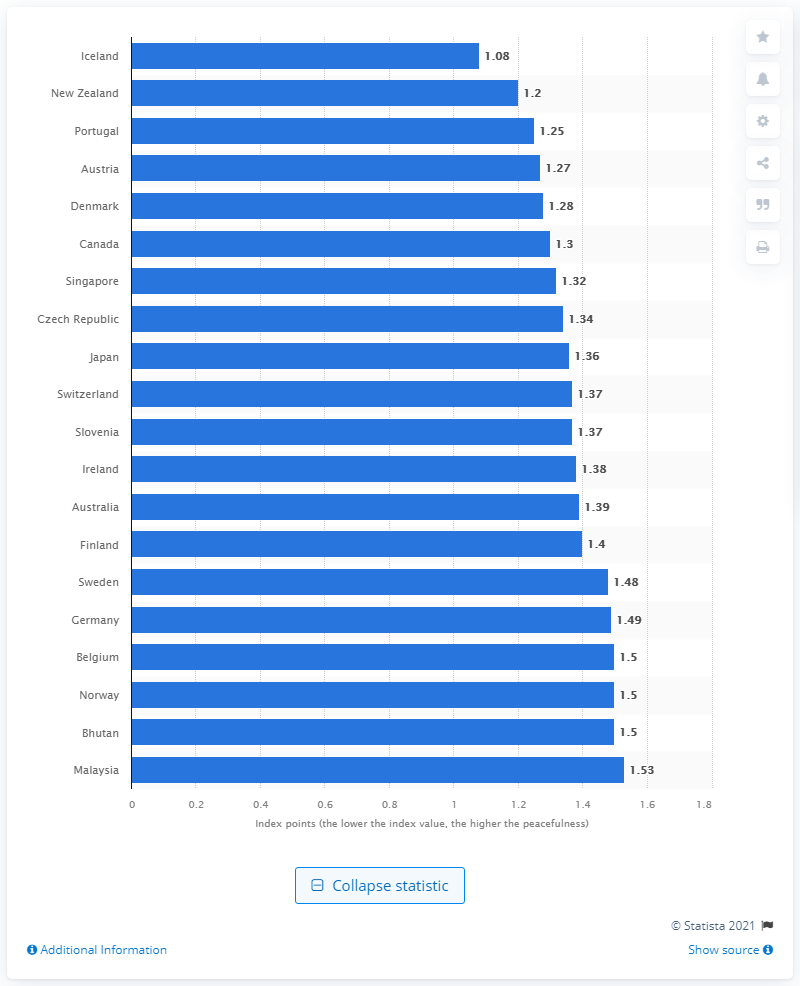Mention a couple of crucial points in this snapshot. According to the Global Peace Index, Iceland was the most peaceful country in the world in [year]. 